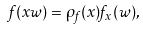Convert formula to latex. <formula><loc_0><loc_0><loc_500><loc_500>f ( x w ) = \rho _ { f } ( x ) f _ { x } ( w ) ,</formula> 